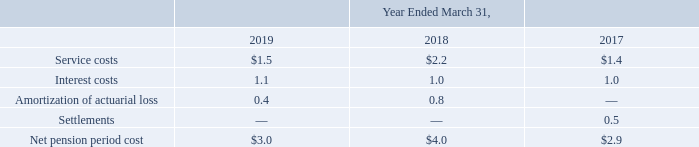Note 15. Employee Benefit Plans
Defined Benefit Plans
The Company has defined benefit pension plans that cover certain French and German employees. Most of these defined pension plans, which were acquired in the Atmel and Microsemi acquisitions, are unfunded. Plan benefits are provided in accordance with local statutory requirements. Benefits are based on years of service and employee compensation levels. Pension liabilities and charges are based upon various assumptions, updated annually, including discount rates, future salary increases, employee turnover, and mortality rates. The Company’s French pension plan provides for termination benefits paid to covered French employees only at retirement, and consists of approximately one to five months of salary. The Company's German pension plan provides for defined benefit payouts for covered German employees following retirement.
The aggregate net pension expense relating to these two plans is as follows (in millions):
Interest costs and amortization of actuarial losses are recorded in the other (loss) income, net line item in the statements of income.
What were plan benefits provided in accordance with? Local statutory requirements. What were the service costs in 2018?
Answer scale should be: million. 2.2. What were the interest costs in 2017?
Answer scale should be: million. 1.0. What was the change in service costs between 2017 and 2018?
Answer scale should be: million. 2.2-1.4
Answer: 0.8. What was the change in the Amortization of actuarial loss between 2018 and 2019?
Answer scale should be: million. 0.4-0.8
Answer: -0.4. What was the percentage change in the net pension period cost between 2018 and 2019?
Answer scale should be: percent. (3.0-4.0)/4.0
Answer: -25. 